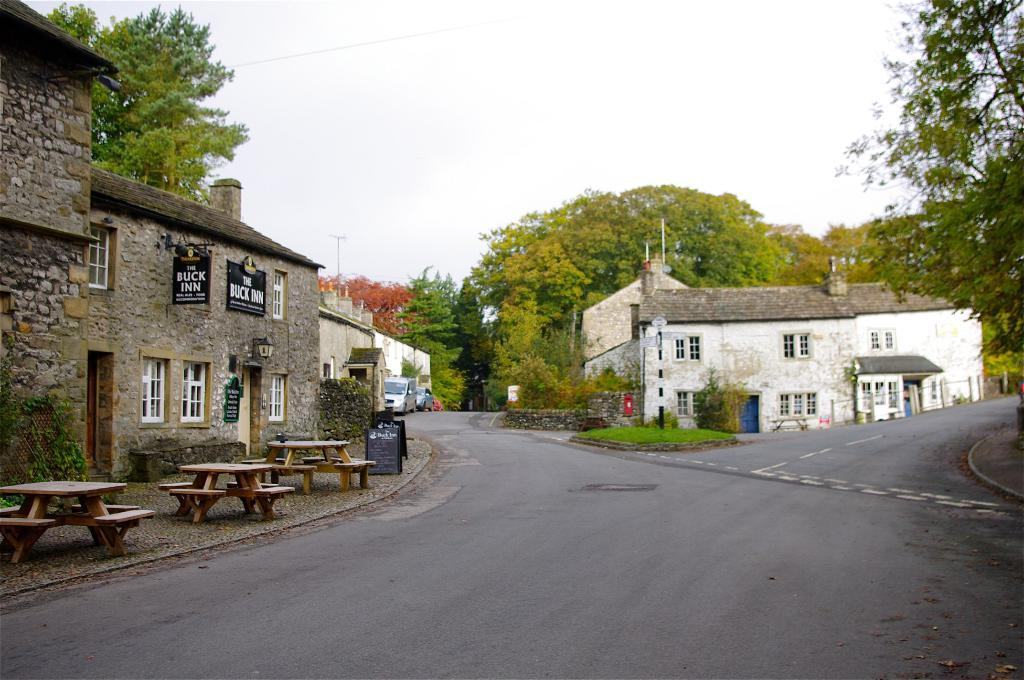What type of road is visible in the image? There is a 2-lane road in the image. What type of structures can be seen alongside the road? There are houses visible in the image. What type of vegetation is present in the image? There are trees in the image. What type of furniture is present in the image? There are tables in the image. Can you touch the tooth that is visible in the image? There is no tooth present in the image. What type of vegetable is growing in the image? There is no vegetable growing in the image. 